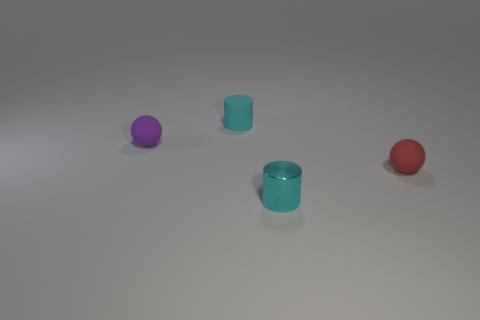Add 2 green matte spheres. How many objects exist? 6 Add 4 purple things. How many purple things exist? 5 Subtract 0 blue balls. How many objects are left? 4 Subtract all large metallic cylinders. Subtract all purple rubber things. How many objects are left? 3 Add 2 tiny red spheres. How many tiny red spheres are left? 3 